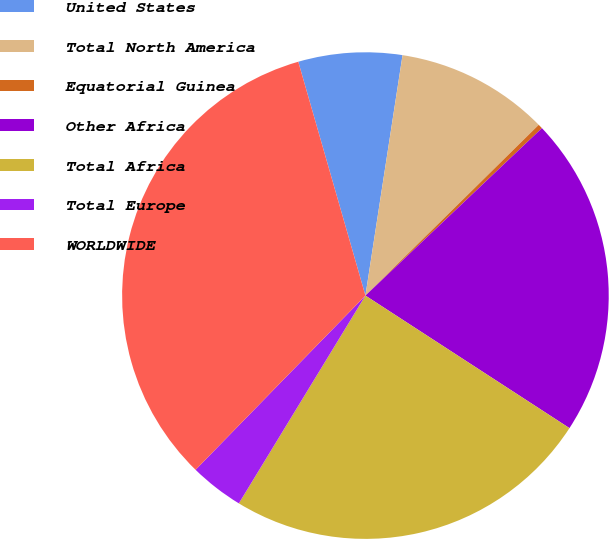<chart> <loc_0><loc_0><loc_500><loc_500><pie_chart><fcel>United States<fcel>Total North America<fcel>Equatorial Guinea<fcel>Other Africa<fcel>Total Africa<fcel>Total Europe<fcel>WORLDWIDE<nl><fcel>6.89%<fcel>10.18%<fcel>0.3%<fcel>21.25%<fcel>24.54%<fcel>3.59%<fcel>33.25%<nl></chart> 